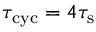Convert formula to latex. <formula><loc_0><loc_0><loc_500><loc_500>\tau _ { c y c } = 4 \tau _ { s }</formula> 